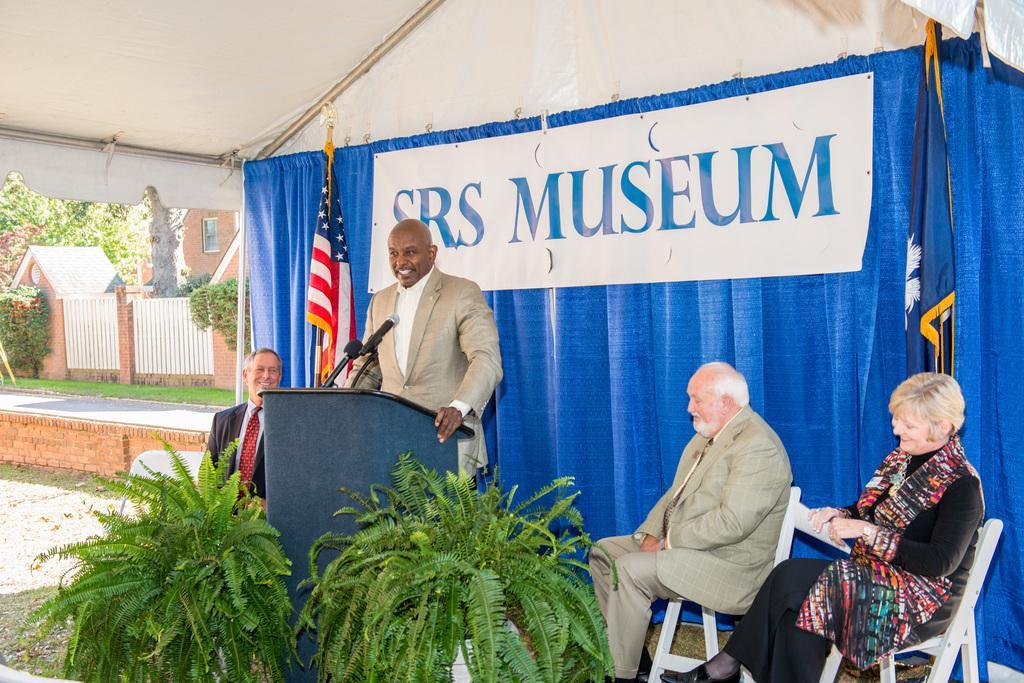Please provide a concise description of this image. In this picture there is a man wearing a brown color coat standing and giving a speech near the speech desk. Beside there is a old man sitting on the chair and a woman wearing black and colorful dress sitting and smiling, beside him. In the in the background there is a blue color curtain and American flag. On the right corner there is a brown color house and white gate. 